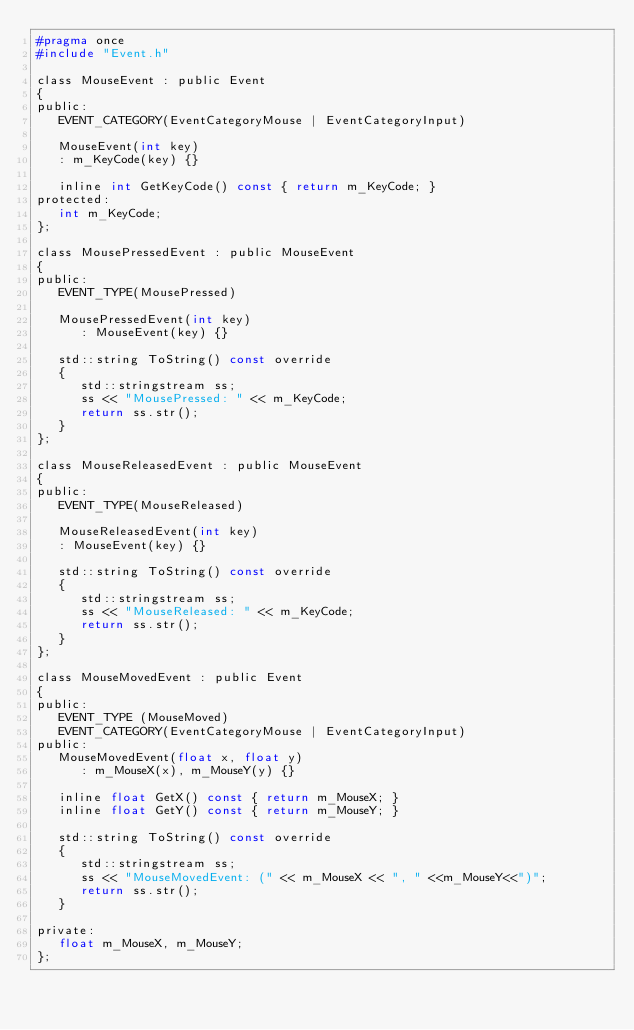<code> <loc_0><loc_0><loc_500><loc_500><_C_>#pragma once
#include "Event.h"

class MouseEvent : public Event
{
public:
   EVENT_CATEGORY(EventCategoryMouse | EventCategoryInput)

   MouseEvent(int key)
   : m_KeyCode(key) {}

   inline int GetKeyCode() const { return m_KeyCode; }
protected:
   int m_KeyCode;
};

class MousePressedEvent : public MouseEvent
{
public:
   EVENT_TYPE(MousePressed)

   MousePressedEvent(int key)
      : MouseEvent(key) {}

   std::string ToString() const override
   {
      std::stringstream ss;
      ss << "MousePressed: " << m_KeyCode;
      return ss.str();
   }
};

class MouseReleasedEvent : public MouseEvent
{
public:
   EVENT_TYPE(MouseReleased)

   MouseReleasedEvent(int key)
   : MouseEvent(key) {}

   std::string ToString() const override
   {
      std::stringstream ss;
      ss << "MouseReleased: " << m_KeyCode;
      return ss.str();
   }
};

class MouseMovedEvent : public Event
{
public:
   EVENT_TYPE (MouseMoved)
   EVENT_CATEGORY(EventCategoryMouse | EventCategoryInput)
public:
   MouseMovedEvent(float x, float y)
      : m_MouseX(x), m_MouseY(y) {}

   inline float GetX() const { return m_MouseX; }
   inline float GetY() const { return m_MouseY; }

   std::string ToString() const override
   {
      std::stringstream ss;
      ss << "MouseMovedEvent: (" << m_MouseX << ", " <<m_MouseY<<")";
      return ss.str();
   }

private:
   float m_MouseX, m_MouseY;
};</code> 